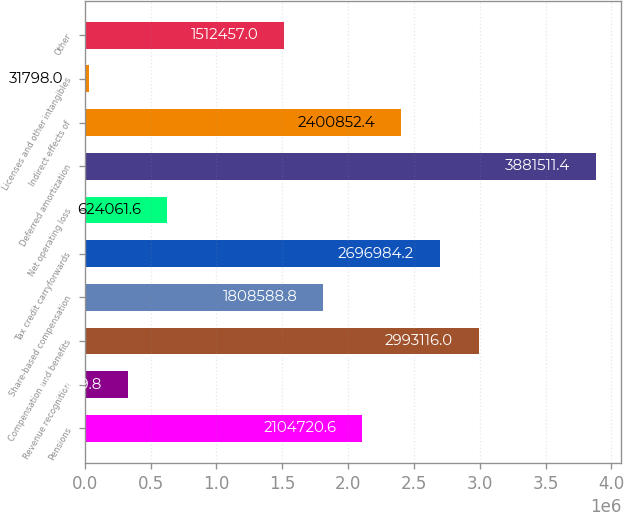Convert chart. <chart><loc_0><loc_0><loc_500><loc_500><bar_chart><fcel>Pensions<fcel>Revenue recognition<fcel>Compensation and benefits<fcel>Share-based compensation<fcel>Tax credit carryforwards<fcel>Net operating loss<fcel>Deferred amortization<fcel>Indirect effects of<fcel>Licenses and other intangibles<fcel>Other<nl><fcel>2.10472e+06<fcel>327930<fcel>2.99312e+06<fcel>1.80859e+06<fcel>2.69698e+06<fcel>624062<fcel>3.88151e+06<fcel>2.40085e+06<fcel>31798<fcel>1.51246e+06<nl></chart> 